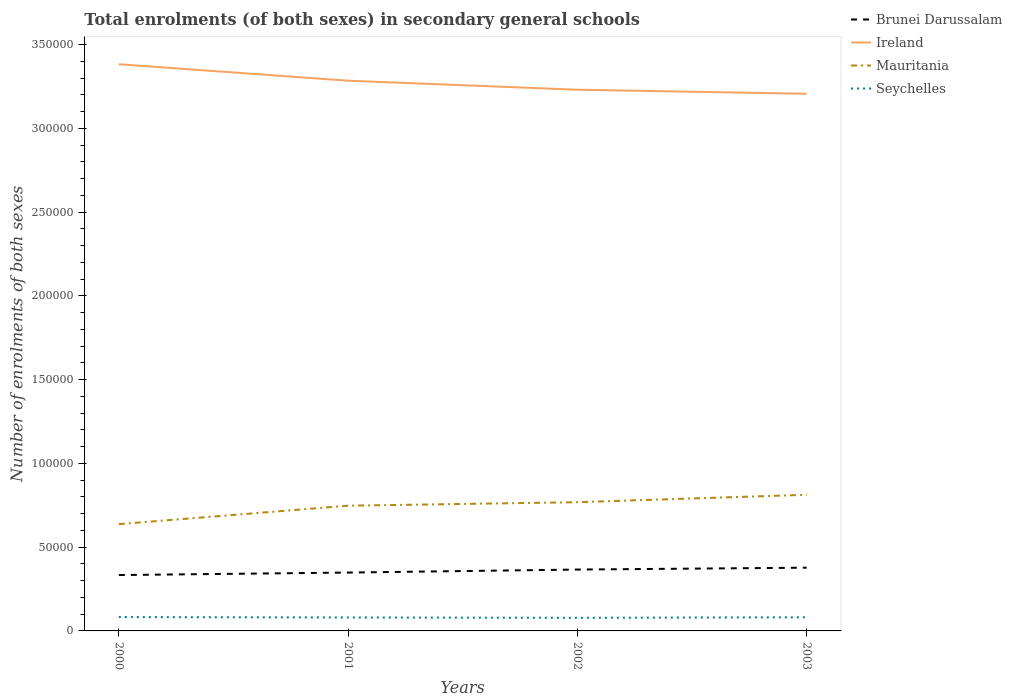Across all years, what is the maximum number of enrolments in secondary schools in Ireland?
Give a very brief answer. 3.21e+05. What is the total number of enrolments in secondary schools in Ireland in the graph?
Keep it short and to the point. 1.52e+04. What is the difference between the highest and the second highest number of enrolments in secondary schools in Mauritania?
Provide a short and direct response. 1.75e+04. What is the difference between the highest and the lowest number of enrolments in secondary schools in Ireland?
Ensure brevity in your answer.  2. Are the values on the major ticks of Y-axis written in scientific E-notation?
Offer a terse response. No. Does the graph contain any zero values?
Give a very brief answer. No. Does the graph contain grids?
Offer a terse response. No. What is the title of the graph?
Keep it short and to the point. Total enrolments (of both sexes) in secondary general schools. What is the label or title of the X-axis?
Provide a short and direct response. Years. What is the label or title of the Y-axis?
Your answer should be very brief. Number of enrolments of both sexes. What is the Number of enrolments of both sexes of Brunei Darussalam in 2000?
Ensure brevity in your answer.  3.33e+04. What is the Number of enrolments of both sexes in Ireland in 2000?
Your answer should be compact. 3.38e+05. What is the Number of enrolments of both sexes in Mauritania in 2000?
Provide a short and direct response. 6.37e+04. What is the Number of enrolments of both sexes in Seychelles in 2000?
Your answer should be very brief. 8280. What is the Number of enrolments of both sexes of Brunei Darussalam in 2001?
Keep it short and to the point. 3.48e+04. What is the Number of enrolments of both sexes in Ireland in 2001?
Ensure brevity in your answer.  3.28e+05. What is the Number of enrolments of both sexes of Mauritania in 2001?
Your answer should be very brief. 7.47e+04. What is the Number of enrolments of both sexes of Seychelles in 2001?
Make the answer very short. 8017. What is the Number of enrolments of both sexes of Brunei Darussalam in 2002?
Give a very brief answer. 3.66e+04. What is the Number of enrolments of both sexes in Ireland in 2002?
Offer a terse response. 3.23e+05. What is the Number of enrolments of both sexes in Mauritania in 2002?
Keep it short and to the point. 7.68e+04. What is the Number of enrolments of both sexes of Seychelles in 2002?
Give a very brief answer. 7826. What is the Number of enrolments of both sexes in Brunei Darussalam in 2003?
Ensure brevity in your answer.  3.77e+04. What is the Number of enrolments of both sexes of Ireland in 2003?
Provide a short and direct response. 3.21e+05. What is the Number of enrolments of both sexes in Mauritania in 2003?
Make the answer very short. 8.13e+04. What is the Number of enrolments of both sexes in Seychelles in 2003?
Offer a terse response. 8137. Across all years, what is the maximum Number of enrolments of both sexes in Brunei Darussalam?
Offer a very short reply. 3.77e+04. Across all years, what is the maximum Number of enrolments of both sexes in Ireland?
Offer a terse response. 3.38e+05. Across all years, what is the maximum Number of enrolments of both sexes in Mauritania?
Offer a terse response. 8.13e+04. Across all years, what is the maximum Number of enrolments of both sexes in Seychelles?
Your answer should be compact. 8280. Across all years, what is the minimum Number of enrolments of both sexes of Brunei Darussalam?
Your answer should be very brief. 3.33e+04. Across all years, what is the minimum Number of enrolments of both sexes in Ireland?
Your answer should be very brief. 3.21e+05. Across all years, what is the minimum Number of enrolments of both sexes of Mauritania?
Keep it short and to the point. 6.37e+04. Across all years, what is the minimum Number of enrolments of both sexes in Seychelles?
Keep it short and to the point. 7826. What is the total Number of enrolments of both sexes in Brunei Darussalam in the graph?
Make the answer very short. 1.43e+05. What is the total Number of enrolments of both sexes in Ireland in the graph?
Offer a terse response. 1.31e+06. What is the total Number of enrolments of both sexes of Mauritania in the graph?
Provide a succinct answer. 2.97e+05. What is the total Number of enrolments of both sexes of Seychelles in the graph?
Provide a short and direct response. 3.23e+04. What is the difference between the Number of enrolments of both sexes in Brunei Darussalam in 2000 and that in 2001?
Your answer should be compact. -1490. What is the difference between the Number of enrolments of both sexes of Ireland in 2000 and that in 2001?
Ensure brevity in your answer.  9823. What is the difference between the Number of enrolments of both sexes of Mauritania in 2000 and that in 2001?
Offer a terse response. -1.10e+04. What is the difference between the Number of enrolments of both sexes of Seychelles in 2000 and that in 2001?
Ensure brevity in your answer.  263. What is the difference between the Number of enrolments of both sexes in Brunei Darussalam in 2000 and that in 2002?
Offer a terse response. -3284. What is the difference between the Number of enrolments of both sexes of Ireland in 2000 and that in 2002?
Make the answer very short. 1.52e+04. What is the difference between the Number of enrolments of both sexes of Mauritania in 2000 and that in 2002?
Offer a terse response. -1.31e+04. What is the difference between the Number of enrolments of both sexes in Seychelles in 2000 and that in 2002?
Offer a terse response. 454. What is the difference between the Number of enrolments of both sexes in Brunei Darussalam in 2000 and that in 2003?
Offer a terse response. -4396. What is the difference between the Number of enrolments of both sexes of Ireland in 2000 and that in 2003?
Make the answer very short. 1.76e+04. What is the difference between the Number of enrolments of both sexes in Mauritania in 2000 and that in 2003?
Offer a terse response. -1.75e+04. What is the difference between the Number of enrolments of both sexes of Seychelles in 2000 and that in 2003?
Make the answer very short. 143. What is the difference between the Number of enrolments of both sexes of Brunei Darussalam in 2001 and that in 2002?
Provide a succinct answer. -1794. What is the difference between the Number of enrolments of both sexes in Ireland in 2001 and that in 2002?
Offer a very short reply. 5381. What is the difference between the Number of enrolments of both sexes in Mauritania in 2001 and that in 2002?
Keep it short and to the point. -2095. What is the difference between the Number of enrolments of both sexes of Seychelles in 2001 and that in 2002?
Offer a terse response. 191. What is the difference between the Number of enrolments of both sexes of Brunei Darussalam in 2001 and that in 2003?
Give a very brief answer. -2906. What is the difference between the Number of enrolments of both sexes of Ireland in 2001 and that in 2003?
Your answer should be very brief. 7804. What is the difference between the Number of enrolments of both sexes of Mauritania in 2001 and that in 2003?
Provide a short and direct response. -6536. What is the difference between the Number of enrolments of both sexes of Seychelles in 2001 and that in 2003?
Your answer should be very brief. -120. What is the difference between the Number of enrolments of both sexes of Brunei Darussalam in 2002 and that in 2003?
Ensure brevity in your answer.  -1112. What is the difference between the Number of enrolments of both sexes of Ireland in 2002 and that in 2003?
Give a very brief answer. 2423. What is the difference between the Number of enrolments of both sexes in Mauritania in 2002 and that in 2003?
Ensure brevity in your answer.  -4441. What is the difference between the Number of enrolments of both sexes of Seychelles in 2002 and that in 2003?
Provide a succinct answer. -311. What is the difference between the Number of enrolments of both sexes in Brunei Darussalam in 2000 and the Number of enrolments of both sexes in Ireland in 2001?
Your answer should be compact. -2.95e+05. What is the difference between the Number of enrolments of both sexes of Brunei Darussalam in 2000 and the Number of enrolments of both sexes of Mauritania in 2001?
Keep it short and to the point. -4.14e+04. What is the difference between the Number of enrolments of both sexes of Brunei Darussalam in 2000 and the Number of enrolments of both sexes of Seychelles in 2001?
Your answer should be compact. 2.53e+04. What is the difference between the Number of enrolments of both sexes of Ireland in 2000 and the Number of enrolments of both sexes of Mauritania in 2001?
Provide a succinct answer. 2.64e+05. What is the difference between the Number of enrolments of both sexes in Ireland in 2000 and the Number of enrolments of both sexes in Seychelles in 2001?
Your answer should be very brief. 3.30e+05. What is the difference between the Number of enrolments of both sexes in Mauritania in 2000 and the Number of enrolments of both sexes in Seychelles in 2001?
Keep it short and to the point. 5.57e+04. What is the difference between the Number of enrolments of both sexes of Brunei Darussalam in 2000 and the Number of enrolments of both sexes of Ireland in 2002?
Your answer should be compact. -2.90e+05. What is the difference between the Number of enrolments of both sexes in Brunei Darussalam in 2000 and the Number of enrolments of both sexes in Mauritania in 2002?
Your answer should be very brief. -4.35e+04. What is the difference between the Number of enrolments of both sexes in Brunei Darussalam in 2000 and the Number of enrolments of both sexes in Seychelles in 2002?
Make the answer very short. 2.55e+04. What is the difference between the Number of enrolments of both sexes of Ireland in 2000 and the Number of enrolments of both sexes of Mauritania in 2002?
Offer a terse response. 2.61e+05. What is the difference between the Number of enrolments of both sexes in Ireland in 2000 and the Number of enrolments of both sexes in Seychelles in 2002?
Your answer should be compact. 3.30e+05. What is the difference between the Number of enrolments of both sexes of Mauritania in 2000 and the Number of enrolments of both sexes of Seychelles in 2002?
Your response must be concise. 5.59e+04. What is the difference between the Number of enrolments of both sexes of Brunei Darussalam in 2000 and the Number of enrolments of both sexes of Ireland in 2003?
Give a very brief answer. -2.87e+05. What is the difference between the Number of enrolments of both sexes in Brunei Darussalam in 2000 and the Number of enrolments of both sexes in Mauritania in 2003?
Your response must be concise. -4.79e+04. What is the difference between the Number of enrolments of both sexes in Brunei Darussalam in 2000 and the Number of enrolments of both sexes in Seychelles in 2003?
Your answer should be very brief. 2.52e+04. What is the difference between the Number of enrolments of both sexes of Ireland in 2000 and the Number of enrolments of both sexes of Mauritania in 2003?
Provide a short and direct response. 2.57e+05. What is the difference between the Number of enrolments of both sexes in Ireland in 2000 and the Number of enrolments of both sexes in Seychelles in 2003?
Give a very brief answer. 3.30e+05. What is the difference between the Number of enrolments of both sexes of Mauritania in 2000 and the Number of enrolments of both sexes of Seychelles in 2003?
Provide a short and direct response. 5.56e+04. What is the difference between the Number of enrolments of both sexes in Brunei Darussalam in 2001 and the Number of enrolments of both sexes in Ireland in 2002?
Offer a very short reply. -2.88e+05. What is the difference between the Number of enrolments of both sexes of Brunei Darussalam in 2001 and the Number of enrolments of both sexes of Mauritania in 2002?
Keep it short and to the point. -4.20e+04. What is the difference between the Number of enrolments of both sexes in Brunei Darussalam in 2001 and the Number of enrolments of both sexes in Seychelles in 2002?
Your answer should be compact. 2.70e+04. What is the difference between the Number of enrolments of both sexes of Ireland in 2001 and the Number of enrolments of both sexes of Mauritania in 2002?
Provide a succinct answer. 2.52e+05. What is the difference between the Number of enrolments of both sexes of Ireland in 2001 and the Number of enrolments of both sexes of Seychelles in 2002?
Offer a terse response. 3.21e+05. What is the difference between the Number of enrolments of both sexes in Mauritania in 2001 and the Number of enrolments of both sexes in Seychelles in 2002?
Ensure brevity in your answer.  6.69e+04. What is the difference between the Number of enrolments of both sexes in Brunei Darussalam in 2001 and the Number of enrolments of both sexes in Ireland in 2003?
Your answer should be compact. -2.86e+05. What is the difference between the Number of enrolments of both sexes of Brunei Darussalam in 2001 and the Number of enrolments of both sexes of Mauritania in 2003?
Keep it short and to the point. -4.64e+04. What is the difference between the Number of enrolments of both sexes in Brunei Darussalam in 2001 and the Number of enrolments of both sexes in Seychelles in 2003?
Give a very brief answer. 2.67e+04. What is the difference between the Number of enrolments of both sexes of Ireland in 2001 and the Number of enrolments of both sexes of Mauritania in 2003?
Your answer should be compact. 2.47e+05. What is the difference between the Number of enrolments of both sexes of Ireland in 2001 and the Number of enrolments of both sexes of Seychelles in 2003?
Provide a short and direct response. 3.20e+05. What is the difference between the Number of enrolments of both sexes in Mauritania in 2001 and the Number of enrolments of both sexes in Seychelles in 2003?
Give a very brief answer. 6.66e+04. What is the difference between the Number of enrolments of both sexes of Brunei Darussalam in 2002 and the Number of enrolments of both sexes of Ireland in 2003?
Make the answer very short. -2.84e+05. What is the difference between the Number of enrolments of both sexes of Brunei Darussalam in 2002 and the Number of enrolments of both sexes of Mauritania in 2003?
Your response must be concise. -4.46e+04. What is the difference between the Number of enrolments of both sexes in Brunei Darussalam in 2002 and the Number of enrolments of both sexes in Seychelles in 2003?
Provide a short and direct response. 2.85e+04. What is the difference between the Number of enrolments of both sexes in Ireland in 2002 and the Number of enrolments of both sexes in Mauritania in 2003?
Ensure brevity in your answer.  2.42e+05. What is the difference between the Number of enrolments of both sexes of Ireland in 2002 and the Number of enrolments of both sexes of Seychelles in 2003?
Provide a short and direct response. 3.15e+05. What is the difference between the Number of enrolments of both sexes in Mauritania in 2002 and the Number of enrolments of both sexes in Seychelles in 2003?
Provide a short and direct response. 6.87e+04. What is the average Number of enrolments of both sexes in Brunei Darussalam per year?
Your answer should be very brief. 3.56e+04. What is the average Number of enrolments of both sexes in Ireland per year?
Ensure brevity in your answer.  3.28e+05. What is the average Number of enrolments of both sexes of Mauritania per year?
Provide a short and direct response. 7.41e+04. What is the average Number of enrolments of both sexes in Seychelles per year?
Make the answer very short. 8065. In the year 2000, what is the difference between the Number of enrolments of both sexes in Brunei Darussalam and Number of enrolments of both sexes in Ireland?
Keep it short and to the point. -3.05e+05. In the year 2000, what is the difference between the Number of enrolments of both sexes of Brunei Darussalam and Number of enrolments of both sexes of Mauritania?
Keep it short and to the point. -3.04e+04. In the year 2000, what is the difference between the Number of enrolments of both sexes in Brunei Darussalam and Number of enrolments of both sexes in Seychelles?
Your answer should be very brief. 2.51e+04. In the year 2000, what is the difference between the Number of enrolments of both sexes of Ireland and Number of enrolments of both sexes of Mauritania?
Provide a succinct answer. 2.75e+05. In the year 2000, what is the difference between the Number of enrolments of both sexes in Ireland and Number of enrolments of both sexes in Seychelles?
Ensure brevity in your answer.  3.30e+05. In the year 2000, what is the difference between the Number of enrolments of both sexes in Mauritania and Number of enrolments of both sexes in Seychelles?
Make the answer very short. 5.55e+04. In the year 2001, what is the difference between the Number of enrolments of both sexes of Brunei Darussalam and Number of enrolments of both sexes of Ireland?
Provide a succinct answer. -2.94e+05. In the year 2001, what is the difference between the Number of enrolments of both sexes of Brunei Darussalam and Number of enrolments of both sexes of Mauritania?
Your answer should be compact. -3.99e+04. In the year 2001, what is the difference between the Number of enrolments of both sexes in Brunei Darussalam and Number of enrolments of both sexes in Seychelles?
Keep it short and to the point. 2.68e+04. In the year 2001, what is the difference between the Number of enrolments of both sexes in Ireland and Number of enrolments of both sexes in Mauritania?
Your response must be concise. 2.54e+05. In the year 2001, what is the difference between the Number of enrolments of both sexes of Ireland and Number of enrolments of both sexes of Seychelles?
Give a very brief answer. 3.20e+05. In the year 2001, what is the difference between the Number of enrolments of both sexes in Mauritania and Number of enrolments of both sexes in Seychelles?
Your answer should be very brief. 6.67e+04. In the year 2002, what is the difference between the Number of enrolments of both sexes in Brunei Darussalam and Number of enrolments of both sexes in Ireland?
Your answer should be very brief. -2.86e+05. In the year 2002, what is the difference between the Number of enrolments of both sexes in Brunei Darussalam and Number of enrolments of both sexes in Mauritania?
Your answer should be very brief. -4.02e+04. In the year 2002, what is the difference between the Number of enrolments of both sexes of Brunei Darussalam and Number of enrolments of both sexes of Seychelles?
Offer a terse response. 2.88e+04. In the year 2002, what is the difference between the Number of enrolments of both sexes in Ireland and Number of enrolments of both sexes in Mauritania?
Ensure brevity in your answer.  2.46e+05. In the year 2002, what is the difference between the Number of enrolments of both sexes of Ireland and Number of enrolments of both sexes of Seychelles?
Provide a short and direct response. 3.15e+05. In the year 2002, what is the difference between the Number of enrolments of both sexes in Mauritania and Number of enrolments of both sexes in Seychelles?
Make the answer very short. 6.90e+04. In the year 2003, what is the difference between the Number of enrolments of both sexes of Brunei Darussalam and Number of enrolments of both sexes of Ireland?
Your response must be concise. -2.83e+05. In the year 2003, what is the difference between the Number of enrolments of both sexes in Brunei Darussalam and Number of enrolments of both sexes in Mauritania?
Offer a very short reply. -4.35e+04. In the year 2003, what is the difference between the Number of enrolments of both sexes in Brunei Darussalam and Number of enrolments of both sexes in Seychelles?
Give a very brief answer. 2.96e+04. In the year 2003, what is the difference between the Number of enrolments of both sexes in Ireland and Number of enrolments of both sexes in Mauritania?
Provide a succinct answer. 2.39e+05. In the year 2003, what is the difference between the Number of enrolments of both sexes of Ireland and Number of enrolments of both sexes of Seychelles?
Keep it short and to the point. 3.12e+05. In the year 2003, what is the difference between the Number of enrolments of both sexes of Mauritania and Number of enrolments of both sexes of Seychelles?
Your answer should be compact. 7.31e+04. What is the ratio of the Number of enrolments of both sexes of Brunei Darussalam in 2000 to that in 2001?
Your response must be concise. 0.96. What is the ratio of the Number of enrolments of both sexes of Ireland in 2000 to that in 2001?
Your answer should be compact. 1.03. What is the ratio of the Number of enrolments of both sexes of Mauritania in 2000 to that in 2001?
Offer a terse response. 0.85. What is the ratio of the Number of enrolments of both sexes in Seychelles in 2000 to that in 2001?
Keep it short and to the point. 1.03. What is the ratio of the Number of enrolments of both sexes in Brunei Darussalam in 2000 to that in 2002?
Offer a very short reply. 0.91. What is the ratio of the Number of enrolments of both sexes of Ireland in 2000 to that in 2002?
Give a very brief answer. 1.05. What is the ratio of the Number of enrolments of both sexes in Mauritania in 2000 to that in 2002?
Keep it short and to the point. 0.83. What is the ratio of the Number of enrolments of both sexes in Seychelles in 2000 to that in 2002?
Offer a terse response. 1.06. What is the ratio of the Number of enrolments of both sexes of Brunei Darussalam in 2000 to that in 2003?
Your response must be concise. 0.88. What is the ratio of the Number of enrolments of both sexes of Ireland in 2000 to that in 2003?
Provide a short and direct response. 1.05. What is the ratio of the Number of enrolments of both sexes of Mauritania in 2000 to that in 2003?
Offer a terse response. 0.78. What is the ratio of the Number of enrolments of both sexes in Seychelles in 2000 to that in 2003?
Offer a terse response. 1.02. What is the ratio of the Number of enrolments of both sexes in Brunei Darussalam in 2001 to that in 2002?
Your response must be concise. 0.95. What is the ratio of the Number of enrolments of both sexes in Ireland in 2001 to that in 2002?
Your answer should be compact. 1.02. What is the ratio of the Number of enrolments of both sexes of Mauritania in 2001 to that in 2002?
Your answer should be compact. 0.97. What is the ratio of the Number of enrolments of both sexes of Seychelles in 2001 to that in 2002?
Your response must be concise. 1.02. What is the ratio of the Number of enrolments of both sexes in Brunei Darussalam in 2001 to that in 2003?
Provide a short and direct response. 0.92. What is the ratio of the Number of enrolments of both sexes of Ireland in 2001 to that in 2003?
Ensure brevity in your answer.  1.02. What is the ratio of the Number of enrolments of both sexes of Mauritania in 2001 to that in 2003?
Provide a succinct answer. 0.92. What is the ratio of the Number of enrolments of both sexes of Seychelles in 2001 to that in 2003?
Your response must be concise. 0.99. What is the ratio of the Number of enrolments of both sexes in Brunei Darussalam in 2002 to that in 2003?
Your response must be concise. 0.97. What is the ratio of the Number of enrolments of both sexes of Ireland in 2002 to that in 2003?
Offer a terse response. 1.01. What is the ratio of the Number of enrolments of both sexes of Mauritania in 2002 to that in 2003?
Offer a terse response. 0.95. What is the ratio of the Number of enrolments of both sexes in Seychelles in 2002 to that in 2003?
Your answer should be compact. 0.96. What is the difference between the highest and the second highest Number of enrolments of both sexes in Brunei Darussalam?
Your response must be concise. 1112. What is the difference between the highest and the second highest Number of enrolments of both sexes in Ireland?
Ensure brevity in your answer.  9823. What is the difference between the highest and the second highest Number of enrolments of both sexes of Mauritania?
Provide a succinct answer. 4441. What is the difference between the highest and the second highest Number of enrolments of both sexes of Seychelles?
Your answer should be very brief. 143. What is the difference between the highest and the lowest Number of enrolments of both sexes of Brunei Darussalam?
Offer a very short reply. 4396. What is the difference between the highest and the lowest Number of enrolments of both sexes of Ireland?
Your answer should be very brief. 1.76e+04. What is the difference between the highest and the lowest Number of enrolments of both sexes in Mauritania?
Offer a very short reply. 1.75e+04. What is the difference between the highest and the lowest Number of enrolments of both sexes in Seychelles?
Offer a very short reply. 454. 